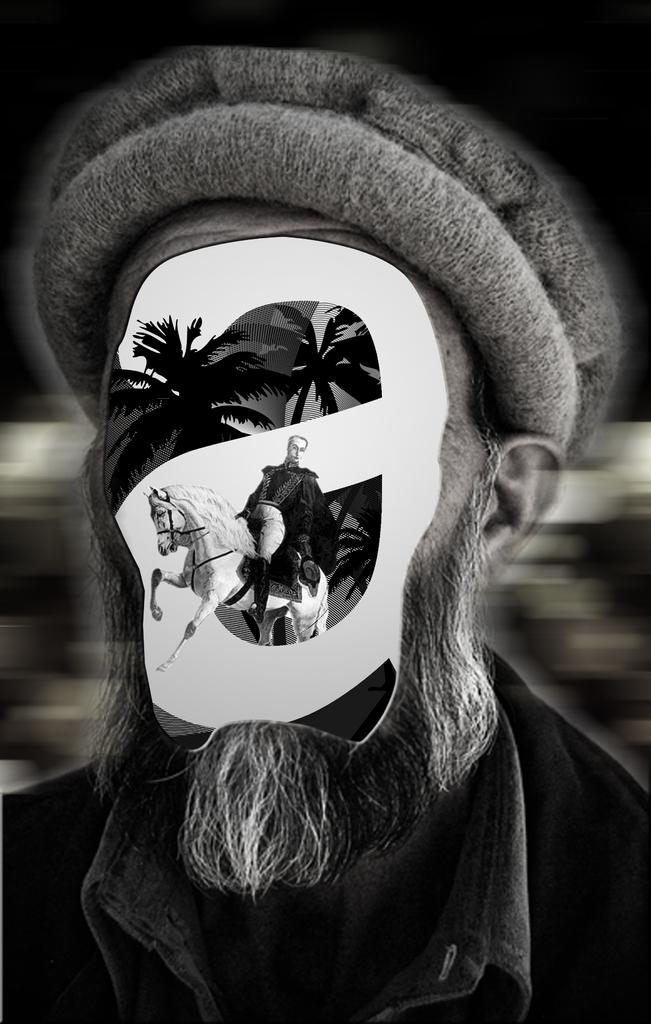What is the color scheme of the image? The image is black and white. What type of image is it? The image is a graphic. What is the main subject of the image? The image depicts a person. What other elements are present in the image? There is a building, a tree, and a horse in the image. Can you describe the position of the horse in the image? The horse is on the person's face. What type of beam is holding up the building in the image? There is no beam present in the image, as it is a graphic and not a photograph of a real building. What decision is the person making in the image? There is no indication of a decision being made in the image. --- 